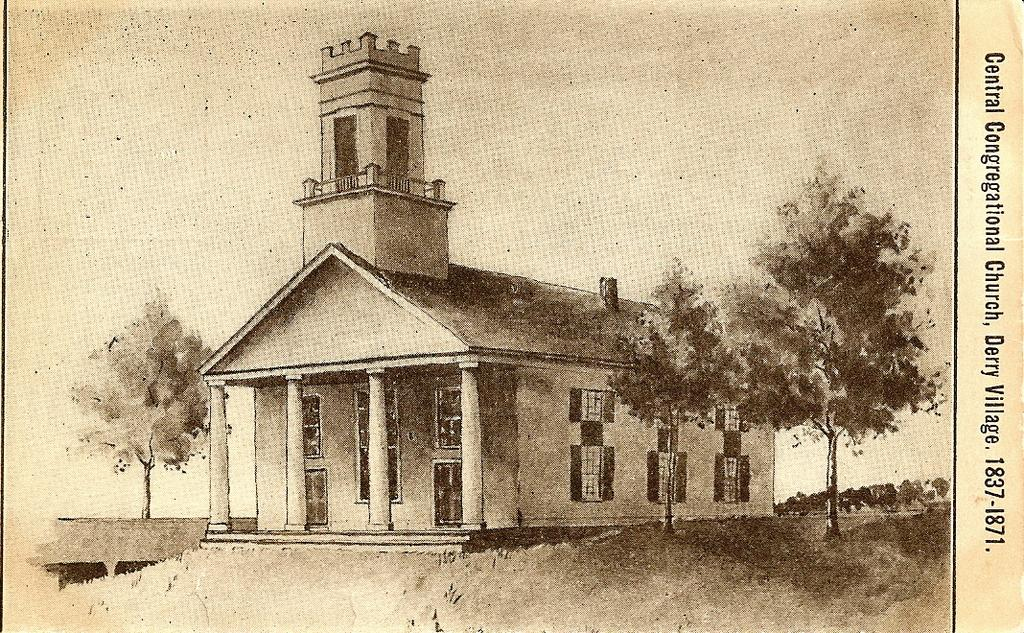What is the main subject of the poster in the image? The poster depicts a house and many trees. Where is the text located on the poster? The text is on the right side of the image. What can be seen in the background of the poster? The sky is visible in the image. How many girls are playing on the farm in the image? There are no girls or farm present in the image; it features a poster with a house, trees, and text. What type of chain is used to secure the animals on the farm in the image? There is no farm or animals present in the image, so there is no chain to secure them. 